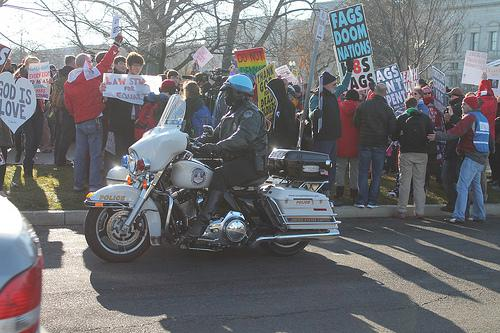Question: who is on a motorbike?
Choices:
A. A person.
B. A biker.
C. A man.
D. A woman.
Answer with the letter. Answer: A Question: when was the picture taken?
Choices:
A. Yesterday.
B. At dawn.
C. During the day.
D. At dusk.
Answer with the letter. Answer: C Question: what are people holding?
Choices:
A. Utensils.
B. Signs.
C. Plates.
D. Silverware.
Answer with the letter. Answer: B 